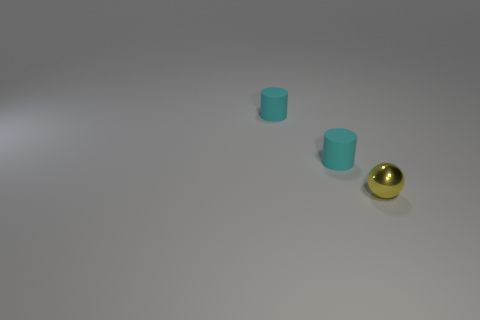Add 1 rubber things. How many objects exist? 4 Subtract all cylinders. How many objects are left? 1 Add 2 tiny cyan rubber things. How many tiny cyan rubber things exist? 4 Subtract 0 purple cylinders. How many objects are left? 3 Subtract all small shiny balls. Subtract all small brown metallic cylinders. How many objects are left? 2 Add 1 tiny yellow metallic objects. How many tiny yellow metallic objects are left? 2 